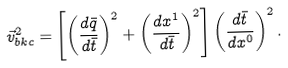Convert formula to latex. <formula><loc_0><loc_0><loc_500><loc_500>\vec { v } ^ { 2 } _ { b k c } = \left [ \left ( \frac { d \bar { q } } { d \bar { t } } \right ) ^ { 2 } + \left ( \frac { d x ^ { 1 } } { d \bar { t } } \right ) ^ { 2 } \right ] \left ( \frac { d \bar { t } } { d x ^ { 0 } } \right ) ^ { 2 } .</formula> 